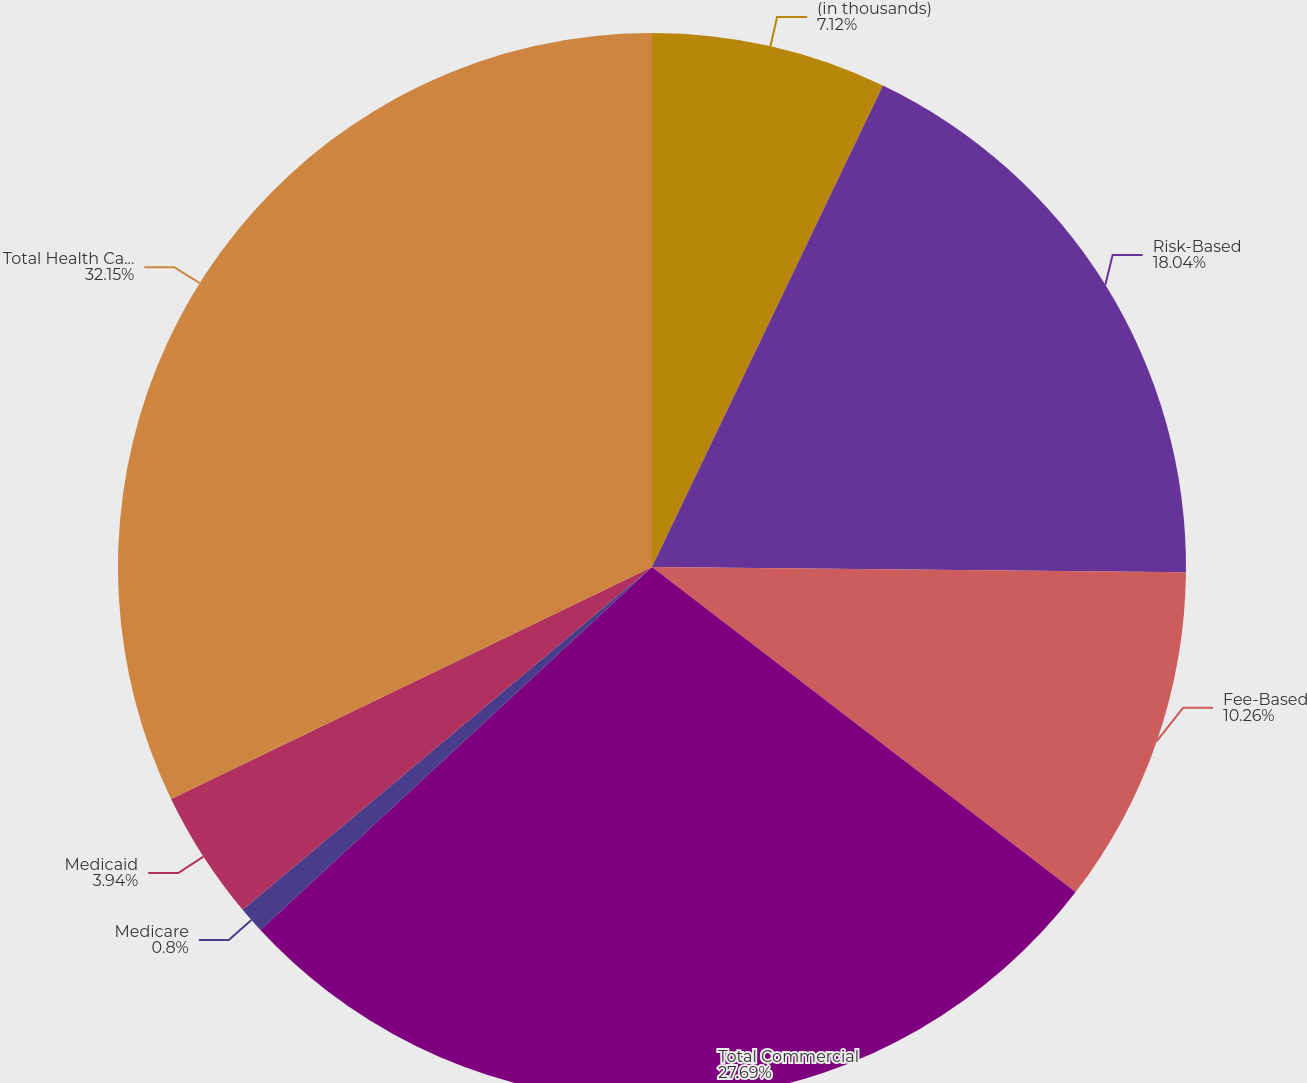Convert chart. <chart><loc_0><loc_0><loc_500><loc_500><pie_chart><fcel>(in thousands)<fcel>Risk-Based<fcel>Fee-Based<fcel>Total Commercial<fcel>Medicare<fcel>Medicaid<fcel>Total Health Care Services<nl><fcel>7.12%<fcel>18.04%<fcel>10.26%<fcel>27.69%<fcel>0.8%<fcel>3.94%<fcel>32.16%<nl></chart> 